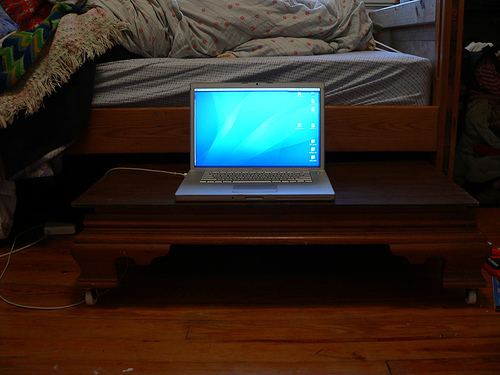<image>Who is sleeping in the bed? I cannot confirm who is sleeping in the bed. Who is sleeping in the bed? It is ambiguous who is sleeping in the bed. It can be someone, man, person or female. 